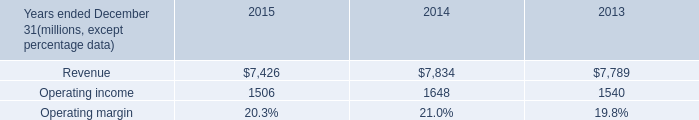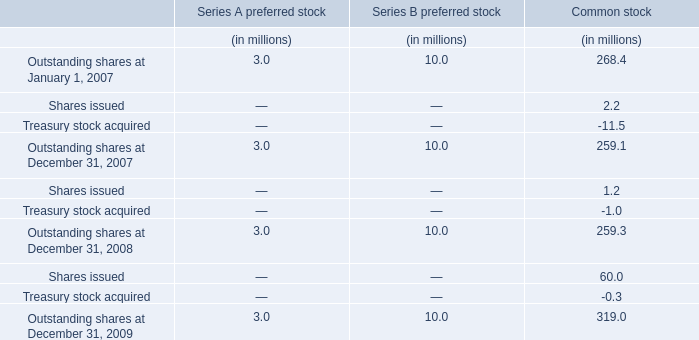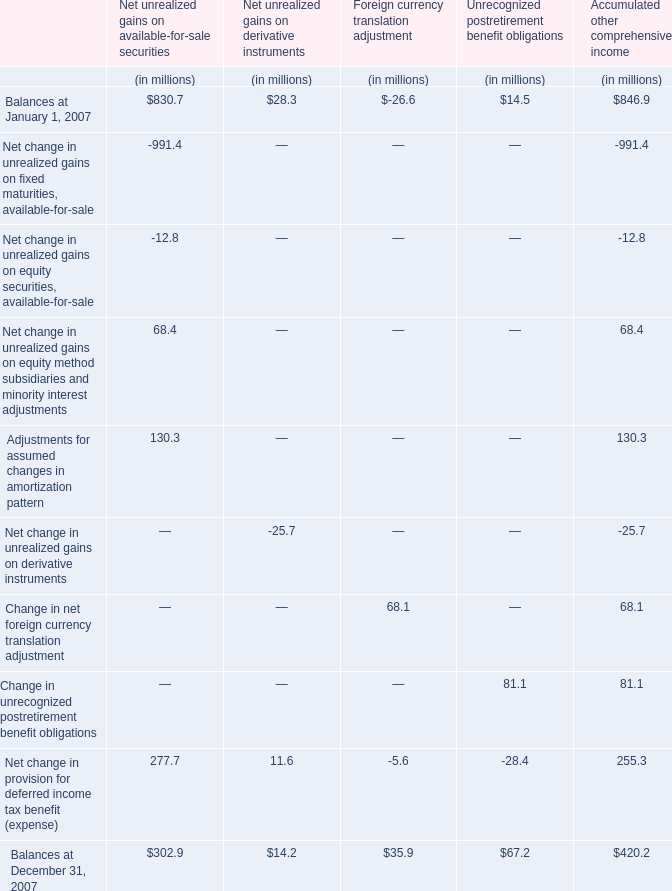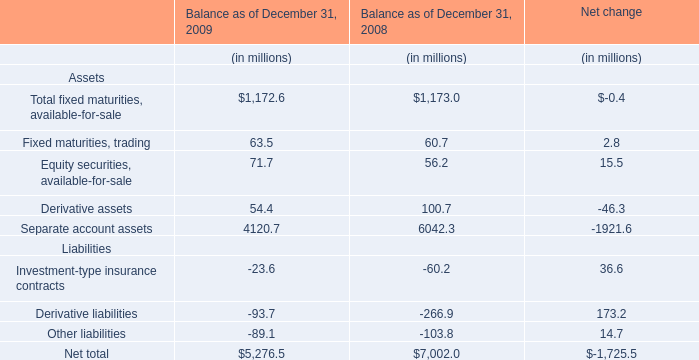What's the total value of all Accumulated other comprehensive income that are in the range of 100 and 1000 in2007? (in million) 
Computations: ((846.9 + 130.3) + 255.3)
Answer: 1232.5. 